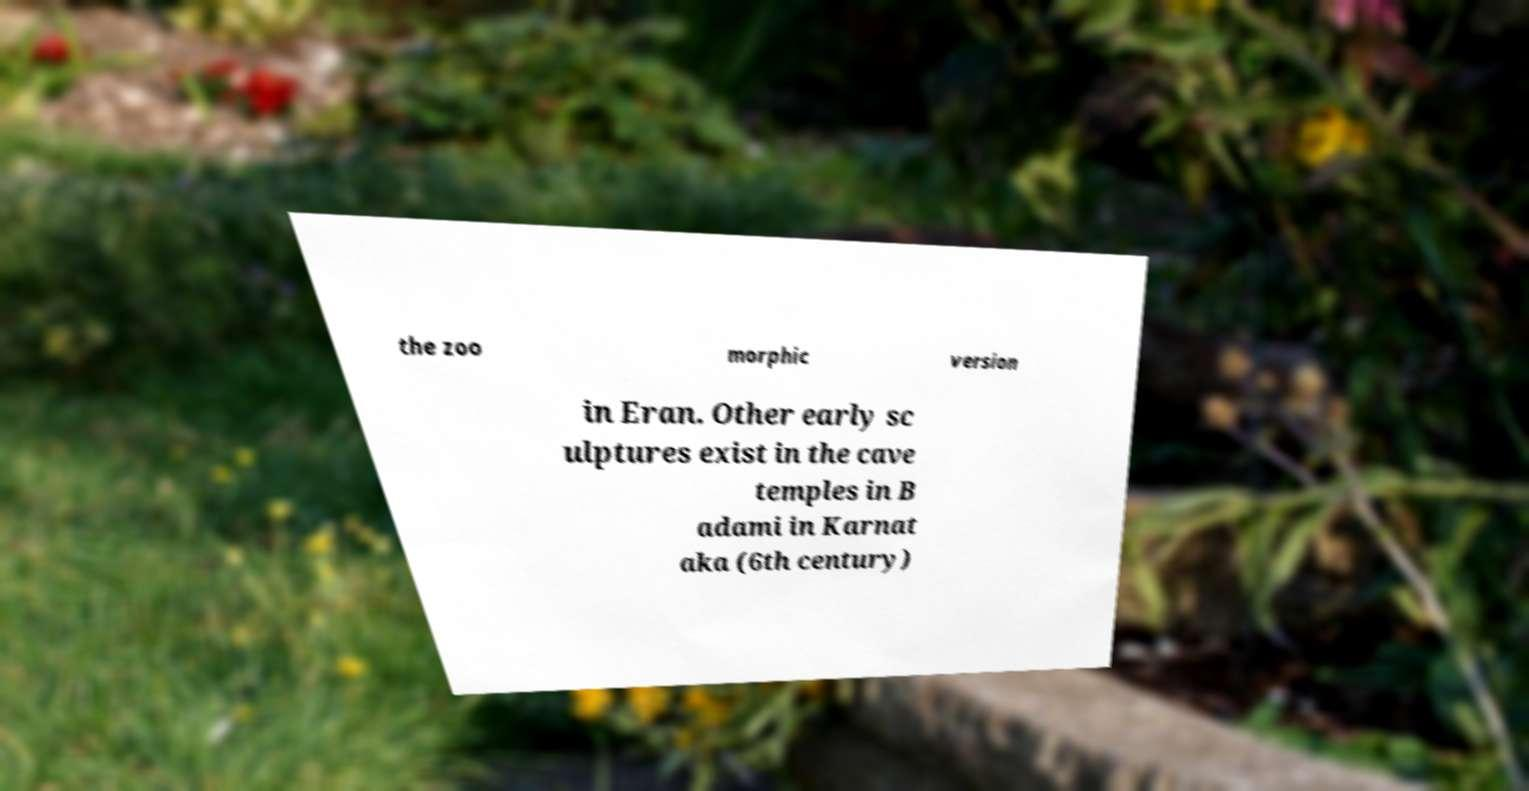Please identify and transcribe the text found in this image. the zoo morphic version in Eran. Other early sc ulptures exist in the cave temples in B adami in Karnat aka (6th century) 